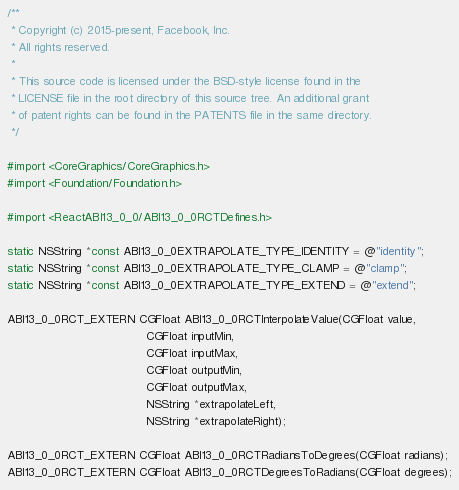Convert code to text. <code><loc_0><loc_0><loc_500><loc_500><_C_>/**
 * Copyright (c) 2015-present, Facebook, Inc.
 * All rights reserved.
 *
 * This source code is licensed under the BSD-style license found in the
 * LICENSE file in the root directory of this source tree. An additional grant
 * of patent rights can be found in the PATENTS file in the same directory.
 */

#import <CoreGraphics/CoreGraphics.h>
#import <Foundation/Foundation.h>

#import <ReactABI13_0_0/ABI13_0_0RCTDefines.h>

static NSString *const ABI13_0_0EXTRAPOLATE_TYPE_IDENTITY = @"identity";
static NSString *const ABI13_0_0EXTRAPOLATE_TYPE_CLAMP = @"clamp";
static NSString *const ABI13_0_0EXTRAPOLATE_TYPE_EXTEND = @"extend";

ABI13_0_0RCT_EXTERN CGFloat ABI13_0_0RCTInterpolateValue(CGFloat value,
                                       CGFloat inputMin,
                                       CGFloat inputMax,
                                       CGFloat outputMin,
                                       CGFloat outputMax,
                                       NSString *extrapolateLeft,
                                       NSString *extrapolateRight);

ABI13_0_0RCT_EXTERN CGFloat ABI13_0_0RCTRadiansToDegrees(CGFloat radians);
ABI13_0_0RCT_EXTERN CGFloat ABI13_0_0RCTDegreesToRadians(CGFloat degrees);
</code> 